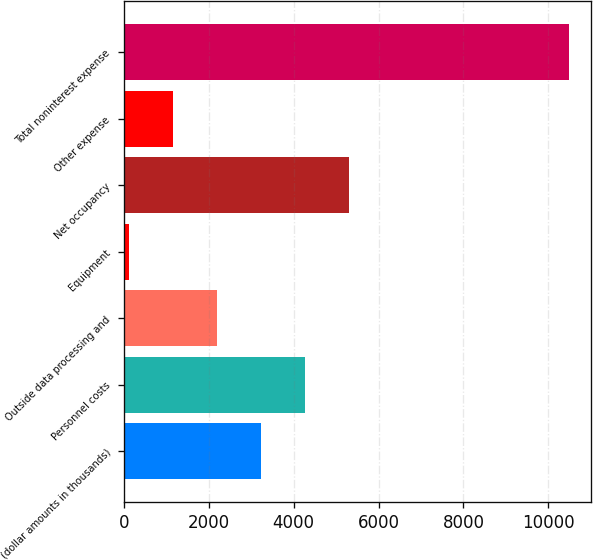<chart> <loc_0><loc_0><loc_500><loc_500><bar_chart><fcel>(dollar amounts in thousands)<fcel>Personnel costs<fcel>Outside data processing and<fcel>Equipment<fcel>Net occupancy<fcel>Other expense<fcel>Total noninterest expense<nl><fcel>3224<fcel>4262<fcel>2186<fcel>110<fcel>5300<fcel>1148<fcel>10490<nl></chart> 